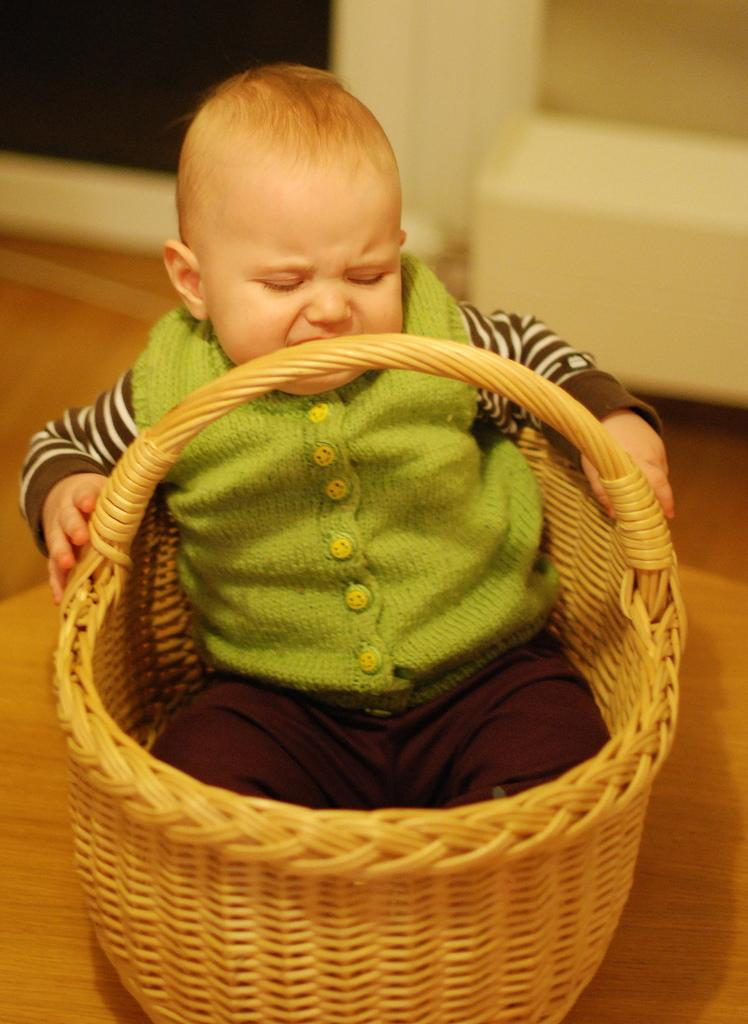Who is the main subject in the image? There is a boy in the image. What is the boy doing in the image? The boy is sitting in a basket. Where is the basket located in the image? The basket is placed on a surface. What type of rabbit can be seen hopping around the boy in the image? There is no rabbit present in the image. What type of market is visible in the background of the image? There is no market visible in the image; it only features a boy sitting in a basket on a surface. 